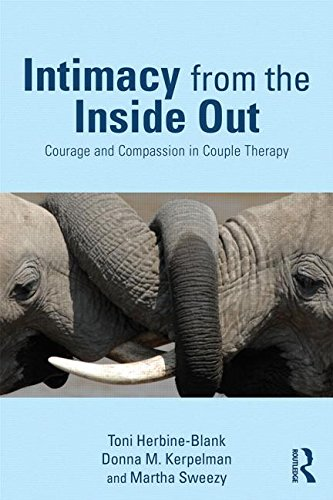Who is the author of this book? The book 'Intimacy from the Inside Out: Courage and Compassion in Couple Therapy' is authored by Toni Herbine-Blank, along with co-authors Donna M. Kerpelman and Martha Sweezy, known for their contributions to psychological therapies. 